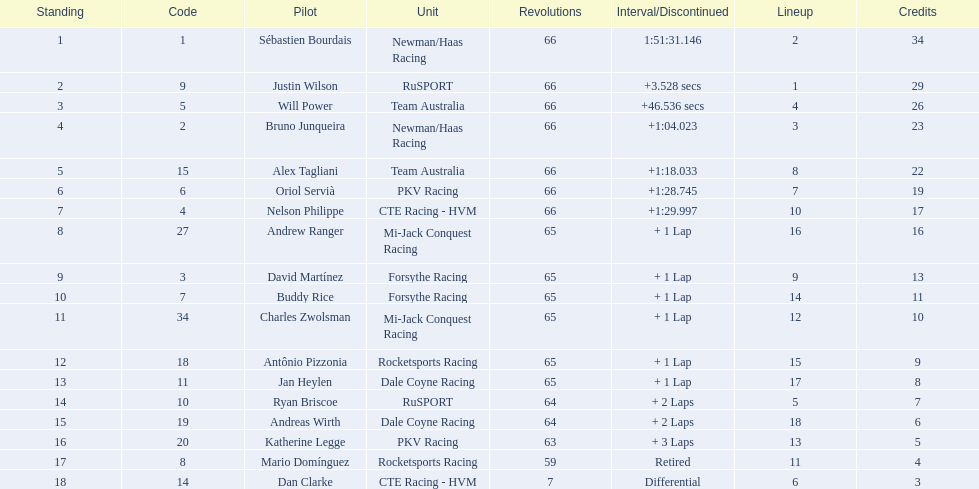Which driver has the same number as his/her position? Sébastien Bourdais. 